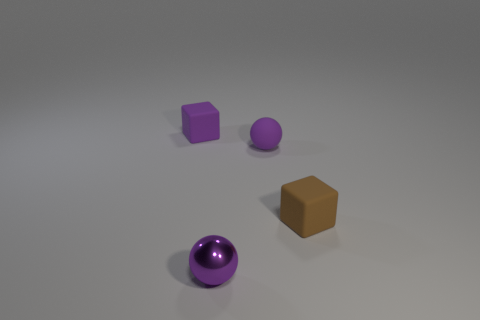Are there more small purple metal balls than big things?
Provide a short and direct response. Yes. What number of things are tiny cubes that are on the left side of the small rubber ball or blue rubber cylinders?
Your response must be concise. 1. Are the brown block and the purple block made of the same material?
Offer a very short reply. Yes. The other rubber object that is the same shape as the brown thing is what size?
Your response must be concise. Small. Do the thing that is in front of the small brown block and the purple matte object that is on the right side of the purple rubber block have the same shape?
Make the answer very short. Yes. How many other things are there of the same material as the brown block?
Offer a very short reply. 2. What is the color of the small rubber block that is on the right side of the cube that is on the left side of the purple sphere that is in front of the small brown object?
Provide a short and direct response. Brown. There is a matte thing that is both right of the shiny object and left of the brown thing; what is its shape?
Give a very brief answer. Sphere. There is a block left of the small metallic ball to the right of the small purple rubber cube; what is its color?
Provide a succinct answer. Purple. There is a rubber thing that is to the left of the ball that is behind the rubber object right of the small rubber ball; what is its shape?
Offer a very short reply. Cube. 